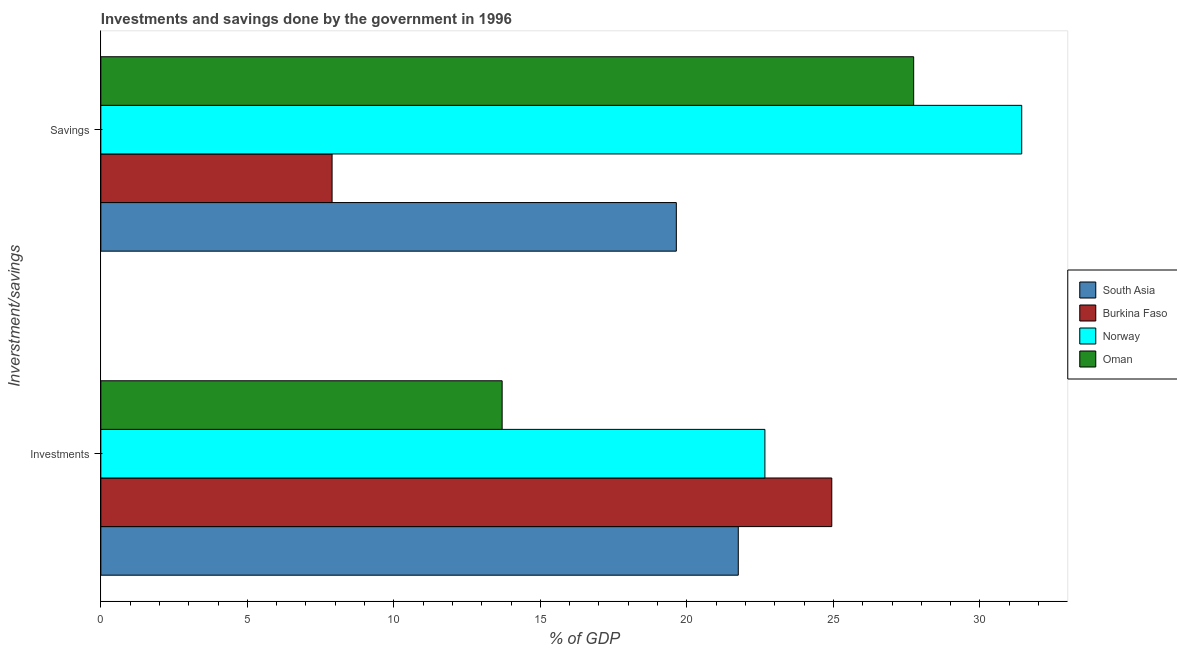Are the number of bars per tick equal to the number of legend labels?
Give a very brief answer. Yes. How many bars are there on the 2nd tick from the top?
Your answer should be very brief. 4. What is the label of the 2nd group of bars from the top?
Provide a short and direct response. Investments. What is the investments of government in Norway?
Give a very brief answer. 22.66. Across all countries, what is the maximum savings of government?
Offer a terse response. 31.43. Across all countries, what is the minimum investments of government?
Ensure brevity in your answer.  13.7. In which country was the investments of government maximum?
Make the answer very short. Burkina Faso. In which country was the investments of government minimum?
Provide a succinct answer. Oman. What is the total savings of government in the graph?
Offer a terse response. 86.7. What is the difference between the savings of government in Burkina Faso and that in Oman?
Give a very brief answer. -19.85. What is the difference between the savings of government in Norway and the investments of government in Burkina Faso?
Your response must be concise. 6.48. What is the average investments of government per country?
Your answer should be compact. 20.76. What is the difference between the savings of government and investments of government in Burkina Faso?
Your answer should be compact. -17.05. In how many countries, is the savings of government greater than 31 %?
Your answer should be very brief. 1. What is the ratio of the savings of government in Oman to that in South Asia?
Give a very brief answer. 1.41. Is the investments of government in South Asia less than that in Norway?
Your answer should be very brief. Yes. What does the 4th bar from the bottom in Savings represents?
Ensure brevity in your answer.  Oman. How many bars are there?
Your response must be concise. 8. Are all the bars in the graph horizontal?
Give a very brief answer. Yes. Are the values on the major ticks of X-axis written in scientific E-notation?
Keep it short and to the point. No. Does the graph contain any zero values?
Offer a very short reply. No. Does the graph contain grids?
Make the answer very short. No. Where does the legend appear in the graph?
Ensure brevity in your answer.  Center right. How many legend labels are there?
Your answer should be compact. 4. How are the legend labels stacked?
Keep it short and to the point. Vertical. What is the title of the graph?
Your answer should be very brief. Investments and savings done by the government in 1996. Does "Isle of Man" appear as one of the legend labels in the graph?
Offer a terse response. No. What is the label or title of the X-axis?
Provide a short and direct response. % of GDP. What is the label or title of the Y-axis?
Keep it short and to the point. Inverstment/savings. What is the % of GDP in South Asia in Investments?
Keep it short and to the point. 21.75. What is the % of GDP of Burkina Faso in Investments?
Provide a short and direct response. 24.94. What is the % of GDP in Norway in Investments?
Offer a very short reply. 22.66. What is the % of GDP in Oman in Investments?
Offer a very short reply. 13.7. What is the % of GDP of South Asia in Savings?
Ensure brevity in your answer.  19.64. What is the % of GDP of Burkina Faso in Savings?
Your answer should be compact. 7.89. What is the % of GDP in Norway in Savings?
Give a very brief answer. 31.43. What is the % of GDP in Oman in Savings?
Make the answer very short. 27.74. Across all Inverstment/savings, what is the maximum % of GDP in South Asia?
Offer a very short reply. 21.75. Across all Inverstment/savings, what is the maximum % of GDP of Burkina Faso?
Give a very brief answer. 24.94. Across all Inverstment/savings, what is the maximum % of GDP of Norway?
Your response must be concise. 31.43. Across all Inverstment/savings, what is the maximum % of GDP of Oman?
Provide a short and direct response. 27.74. Across all Inverstment/savings, what is the minimum % of GDP of South Asia?
Give a very brief answer. 19.64. Across all Inverstment/savings, what is the minimum % of GDP in Burkina Faso?
Offer a very short reply. 7.89. Across all Inverstment/savings, what is the minimum % of GDP of Norway?
Provide a succinct answer. 22.66. Across all Inverstment/savings, what is the minimum % of GDP of Oman?
Give a very brief answer. 13.7. What is the total % of GDP in South Asia in the graph?
Offer a terse response. 41.39. What is the total % of GDP of Burkina Faso in the graph?
Keep it short and to the point. 32.84. What is the total % of GDP of Norway in the graph?
Provide a short and direct response. 54.09. What is the total % of GDP of Oman in the graph?
Offer a terse response. 41.43. What is the difference between the % of GDP in South Asia in Investments and that in Savings?
Your answer should be compact. 2.11. What is the difference between the % of GDP of Burkina Faso in Investments and that in Savings?
Ensure brevity in your answer.  17.05. What is the difference between the % of GDP in Norway in Investments and that in Savings?
Give a very brief answer. -8.76. What is the difference between the % of GDP in Oman in Investments and that in Savings?
Keep it short and to the point. -14.04. What is the difference between the % of GDP in South Asia in Investments and the % of GDP in Burkina Faso in Savings?
Your answer should be compact. 13.86. What is the difference between the % of GDP of South Asia in Investments and the % of GDP of Norway in Savings?
Offer a terse response. -9.67. What is the difference between the % of GDP of South Asia in Investments and the % of GDP of Oman in Savings?
Ensure brevity in your answer.  -5.99. What is the difference between the % of GDP of Burkina Faso in Investments and the % of GDP of Norway in Savings?
Give a very brief answer. -6.48. What is the difference between the % of GDP in Burkina Faso in Investments and the % of GDP in Oman in Savings?
Ensure brevity in your answer.  -2.79. What is the difference between the % of GDP in Norway in Investments and the % of GDP in Oman in Savings?
Give a very brief answer. -5.08. What is the average % of GDP in South Asia per Inverstment/savings?
Your answer should be very brief. 20.7. What is the average % of GDP in Burkina Faso per Inverstment/savings?
Offer a very short reply. 16.42. What is the average % of GDP in Norway per Inverstment/savings?
Provide a succinct answer. 27.04. What is the average % of GDP in Oman per Inverstment/savings?
Provide a succinct answer. 20.72. What is the difference between the % of GDP of South Asia and % of GDP of Burkina Faso in Investments?
Offer a very short reply. -3.19. What is the difference between the % of GDP of South Asia and % of GDP of Norway in Investments?
Your response must be concise. -0.91. What is the difference between the % of GDP of South Asia and % of GDP of Oman in Investments?
Your answer should be very brief. 8.06. What is the difference between the % of GDP in Burkina Faso and % of GDP in Norway in Investments?
Your response must be concise. 2.28. What is the difference between the % of GDP of Burkina Faso and % of GDP of Oman in Investments?
Offer a terse response. 11.25. What is the difference between the % of GDP in Norway and % of GDP in Oman in Investments?
Ensure brevity in your answer.  8.97. What is the difference between the % of GDP of South Asia and % of GDP of Burkina Faso in Savings?
Provide a succinct answer. 11.75. What is the difference between the % of GDP of South Asia and % of GDP of Norway in Savings?
Your answer should be very brief. -11.79. What is the difference between the % of GDP in South Asia and % of GDP in Oman in Savings?
Provide a succinct answer. -8.1. What is the difference between the % of GDP of Burkina Faso and % of GDP of Norway in Savings?
Ensure brevity in your answer.  -23.54. What is the difference between the % of GDP of Burkina Faso and % of GDP of Oman in Savings?
Provide a succinct answer. -19.85. What is the difference between the % of GDP in Norway and % of GDP in Oman in Savings?
Keep it short and to the point. 3.69. What is the ratio of the % of GDP of South Asia in Investments to that in Savings?
Offer a very short reply. 1.11. What is the ratio of the % of GDP in Burkina Faso in Investments to that in Savings?
Offer a terse response. 3.16. What is the ratio of the % of GDP of Norway in Investments to that in Savings?
Make the answer very short. 0.72. What is the ratio of the % of GDP in Oman in Investments to that in Savings?
Offer a terse response. 0.49. What is the difference between the highest and the second highest % of GDP in South Asia?
Offer a terse response. 2.11. What is the difference between the highest and the second highest % of GDP of Burkina Faso?
Your answer should be very brief. 17.05. What is the difference between the highest and the second highest % of GDP in Norway?
Provide a succinct answer. 8.76. What is the difference between the highest and the second highest % of GDP of Oman?
Ensure brevity in your answer.  14.04. What is the difference between the highest and the lowest % of GDP in South Asia?
Your answer should be compact. 2.11. What is the difference between the highest and the lowest % of GDP in Burkina Faso?
Your response must be concise. 17.05. What is the difference between the highest and the lowest % of GDP of Norway?
Keep it short and to the point. 8.76. What is the difference between the highest and the lowest % of GDP of Oman?
Keep it short and to the point. 14.04. 